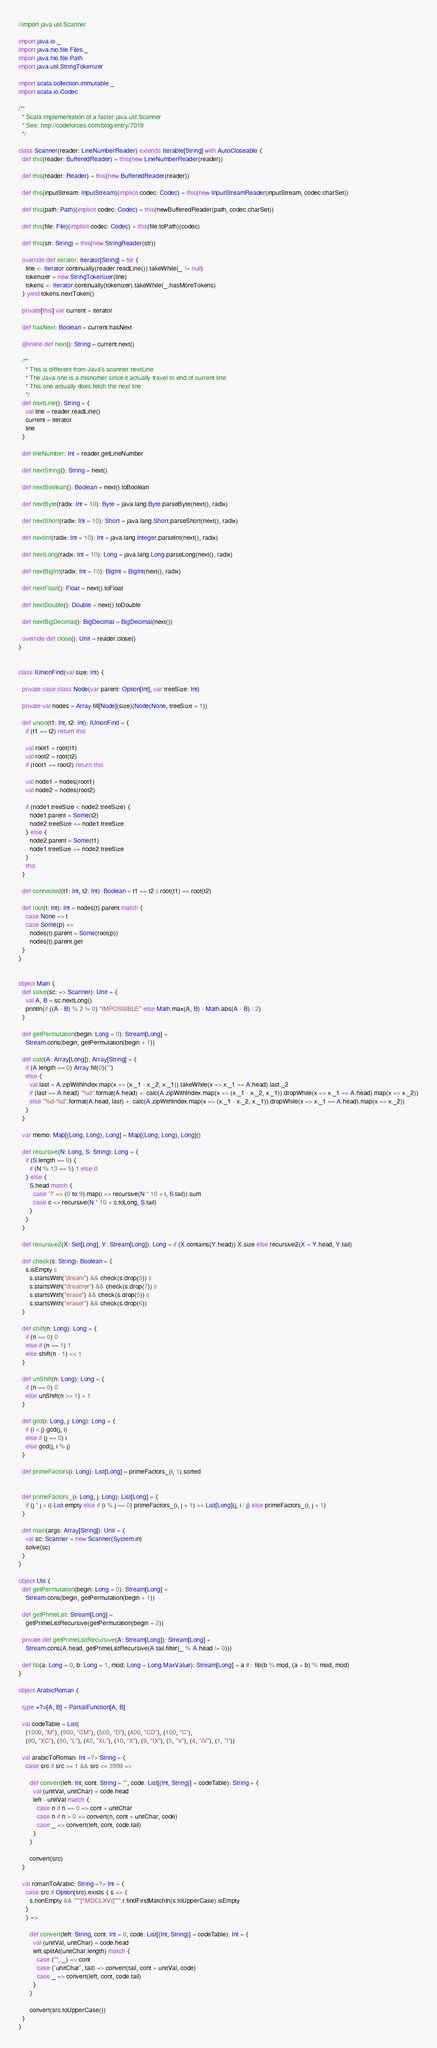<code> <loc_0><loc_0><loc_500><loc_500><_Scala_>//import java.util.Scanner

import java.io._
import java.nio.file.Files._
import java.nio.file.Path
import java.util.StringTokenizer

import scala.collection.immutable._
import scala.io.Codec

/**
  * Scala implementation of a faster java.util.Scanner
  * See: http://codeforces.com/blog/entry/7018
  */

class Scanner(reader: LineNumberReader) extends Iterable[String] with AutoCloseable {
  def this(reader: BufferedReader) = this(new LineNumberReader(reader))

  def this(reader: Reader) = this(new BufferedReader(reader))

  def this(inputStream: InputStream)(implicit codec: Codec) = this(new InputStreamReader(inputStream, codec.charSet))

  def this(path: Path)(implicit codec: Codec) = this(newBufferedReader(path, codec.charSet))

  def this(file: File)(implicit codec: Codec) = this(file.toPath)(codec)

  def this(str: String) = this(new StringReader(str))

  override def iterator: Iterator[String] = for {
    line <- Iterator.continually(reader.readLine()).takeWhile(_ != null)
    tokenizer = new StringTokenizer(line)
    tokens <- Iterator.continually(tokenizer).takeWhile(_.hasMoreTokens)
  } yield tokens.nextToken()

  private[this] var current = iterator

  def hasNext: Boolean = current.hasNext

  @inline def next(): String = current.next()

  /**
    * This is different from Java's scanner.nextLine
    * The Java one is a misnomer since it actually travel to end of current line
    * This one actually does fetch the next line
    */
  def nextLine(): String = {
    val line = reader.readLine()
    current = iterator
    line
  }

  def lineNumber: Int = reader.getLineNumber

  def nextString(): String = next()

  def nextBoolean(): Boolean = next().toBoolean

  def nextByte(radix: Int = 10): Byte = java.lang.Byte.parseByte(next(), radix)

  def nextShort(radix: Int = 10): Short = java.lang.Short.parseShort(next(), radix)

  def nextInt(radix: Int = 10): Int = java.lang.Integer.parseInt(next(), radix)

  def nextLong(radix: Int = 10): Long = java.lang.Long.parseLong(next(), radix)

  def nextBigInt(radix: Int = 10): BigInt = BigInt(next(), radix)

  def nextFloat(): Float = next().toFloat

  def nextDouble(): Double = next().toDouble

  def nextBigDecimal(): BigDecimal = BigDecimal(next())

  override def close(): Unit = reader.close()
}


class IUnionFind(val size: Int) {

  private case class Node(var parent: Option[Int], var treeSize: Int)

  private val nodes = Array.fill[Node](size)(Node(None, treeSize = 1))

  def union(t1: Int, t2: Int): IUnionFind = {
    if (t1 == t2) return this

    val root1 = root(t1)
    val root2 = root(t2)
    if (root1 == root2) return this

    val node1 = nodes(root1)
    val node2 = nodes(root2)

    if (node1.treeSize < node2.treeSize) {
      node1.parent = Some(t2)
      node2.treeSize += node1.treeSize
    } else {
      node2.parent = Some(t1)
      node1.treeSize += node2.treeSize
    }
    this
  }

  def connected(t1: Int, t2: Int): Boolean = t1 == t2 || root(t1) == root(t2)

  def root(t: Int): Int = nodes(t).parent match {
    case None => t
    case Some(p) =>
      nodes(t).parent = Some(root(p))
      nodes(t).parent.get
  }
}


object Main {
  def solve(sc: => Scanner): Unit = {
    val A, B = sc.nextLong()
    println(if ((A - B) % 2 != 0) "IMPOSSIBLE" else Math.max(A, B) - Math.abs(A - B) / 2)
  }

  def getPermutation(begin: Long = 0): Stream[Long] =
    Stream.cons(begin, getPermutation(begin + 1))

  def calc(A: Array[Long]): Array[String] = {
    if (A.length == 0) Array.fill(0)("")
    else {
      val last = A.zipWithIndex.map(x => (x._1 - x._2, x._1)).takeWhile(x => x._1 == A.head).last._2
      if (last == A.head) "%d".format(A.head) +: calc(A.zipWithIndex.map(x => (x._1 - x._2, x._1)).dropWhile(x => x._1 == A.head).map(x => x._2))
      else "%d-%d".format(A.head, last) +: calc(A.zipWithIndex.map(x => (x._1 - x._2, x._1)).dropWhile(x => x._1 == A.head).map(x => x._2))
    }
  }

  var memo: Map[(Long, Long), Long] = Map[(Long, Long), Long]()

  def recursive(N: Long, S: String): Long = {
    if (S.length == 0) {
      if (N % 13 == 5) 1 else 0
    } else {
      S.head match {
        case '?' => (0 to 9).map(i => recursive(N * 10 + i, S.tail)).sum
        case c => recursive(N * 10 + c.toLong, S.tail)
      }
    }
  }

  def recursive2(X: Set[Long], Y: Stream[Long]): Long = if (X.contains(Y.head)) X.size else recursive2(X + Y.head, Y.tail)

  def check(s: String): Boolean = {
    s.isEmpty ||
      s.startsWith("dream") && check(s.drop(5)) ||
      s.startsWith("dreamer") && check(s.drop(7)) ||
      s.startsWith("erase") && check(s.drop(5)) ||
      s.startsWith("eraser") && check(s.drop(6))
  }

  def shift(n: Long): Long = {
    if (n == 0) 0
    else if (n == 1) 1
    else shift(n - 1) << 1
  }

  def unShift(n: Long): Long = {
    if (n == 0) 0
    else unShift(n >> 1) + 1
  }

  def gcd(i: Long, j: Long): Long = {
    if (i < j) gcd(j, i)
    else if (j == 0) i
    else gcd(j, i % j)
  }

  def primeFactors(i: Long): List[Long] = primeFactors_(i, 1).sorted


  def primeFactors_(i: Long, j: Long): List[Long] = {
    if (j * j > i) List.empty else if (i % j == 0) primeFactors_(i, j + 1) ++ List[Long](j, i / j) else primeFactors_(i, j + 1)
  }

  def main(args: Array[String]): Unit = {
    val sc: Scanner = new Scanner(System.in)
    solve(sc)
  }
}

object Util {
  def getPermutation(begin: Long = 0): Stream[Long] =
    Stream.cons(begin, getPermutation(begin + 1))

  def getPrimeList: Stream[Long] =
    getPrimeListRecursive(getPermutation(begin = 2))

  private def getPrimeListRecursive(A: Stream[Long]): Stream[Long] =
    Stream.cons(A.head, getPrimeListRecursive(A.tail.filter(_ % A.head != 0)))

  def fib(a: Long = 0, b: Long = 1, mod: Long = Long.MaxValue): Stream[Long] = a #:: fib(b % mod, (a + b) % mod, mod)
}

object ArabicRoman {

  type =?>[A, B] = PartialFunction[A, B]

  val codeTable = List(
    (1000, "M"), (900, "CM"), (500, "D"), (400, "CD"), (100, "C"),
    (90, "XC"), (50, "L"), (40, "XL"), (10, "X"), (9, "IX"), (5, "V"), (4, "IV"), (1, "I"))

  val arabicToRoman: Int =?> String = {
    case src if src >= 1 && src <= 3999 =>

      def convert(left: Int, cont: String = "", code: List[(Int, String)] = codeTable): String = {
        val (unitVal, unitChar) = code.head
        left - unitVal match {
          case n if n == 0 => cont + unitChar
          case n if n > 0 => convert(n, cont + unitChar, code)
          case _ => convert(left, cont, code.tail)
        }
      }

      convert(src)
  }

  val romanToArabic: String =?> Int = {
    case src if Option(src).exists { s => {
      s.nonEmpty && """[^MDCLXVI]""".r.findFirstMatchIn(s.toUpperCase).isEmpty
    }
    } =>

      def convert(left: String, cont: Int = 0, code: List[(Int, String)] = codeTable): Int = {
        val (unitVal, unitChar) = code.head
        left.splitAt(unitChar.length) match {
          case ("", _) => cont
          case (`unitChar`, tail) => convert(tail, cont + unitVal, code)
          case _ => convert(left, cont, code.tail)
        }
      }

      convert(src.toUpperCase())
  }
}
</code> 